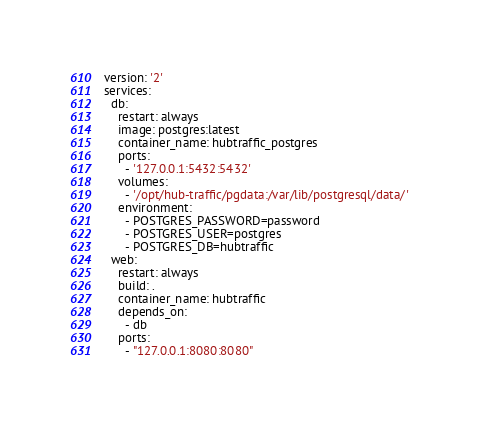Convert code to text. <code><loc_0><loc_0><loc_500><loc_500><_YAML_>version: '2'
services:
  db:
    restart: always
    image: postgres:latest
    container_name: hubtraffic_postgres
    ports:
      - '127.0.0.1:5432:5432'
    volumes:
      - '/opt/hub-traffic/pgdata:/var/lib/postgresql/data/'
    environment:
      - POSTGRES_PASSWORD=password
      - POSTGRES_USER=postgres
      - POSTGRES_DB=hubtraffic
  web:
    restart: always
    build: .
    container_name: hubtraffic
    depends_on:
      - db
    ports:
      - "127.0.0.1:8080:8080"</code> 